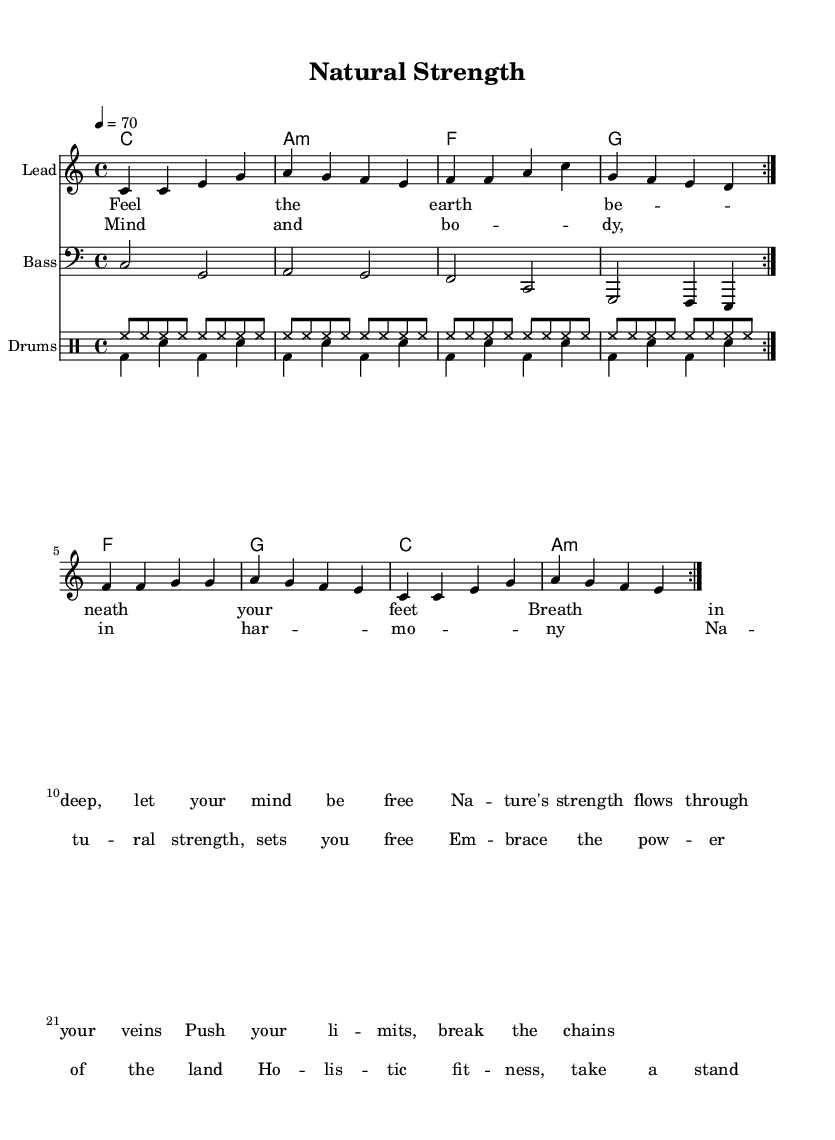What is the key signature of this music? The key signature is indicated by the absence of sharps or flats in the sheet music, which corresponds to C major.
Answer: C major What is the time signature of this music? The time signature is shown at the beginning of the score, represented as 4/4, meaning four beats in a measure and the quarter note gets one beat.
Answer: 4/4 What is the tempo marking for this piece? The tempo marking is visible in the score and indicates the speed of the music; it is set at 70 beats per minute.
Answer: 70 How many times is the melody repeated in the score? The score indicates that the melody section is repeated in the first line, as shown by the "repeat volta 2" marks, which signifies that this section is performed twice.
Answer: 2 What musical form does the song follow based on the lyrics? The structure of the lyrics suggests a common form in reggae music, where verses and choruses alternate; here, specifically, the pattern shows verses followed by choruses.
Answer: Verse-Chorus What thematic element distinguishes this reggae song? The prominent theme of the song ties back to nature and holistic fitness, which is central to the lyrics that discuss the connection between mind, body, and nature.
Answer: Connection to nature What instruments are specified for this piece? The score identifies specific instruments for performance, including a lead instrument, bass, and drums, suggesting a typical reggae band setup.
Answer: Lead, Bass, Drums 